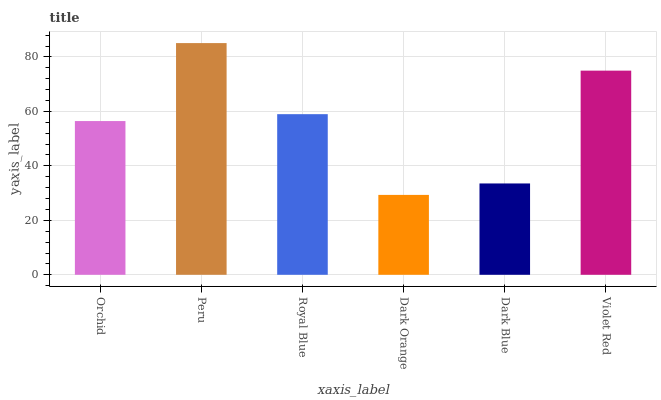Is Dark Orange the minimum?
Answer yes or no. Yes. Is Peru the maximum?
Answer yes or no. Yes. Is Royal Blue the minimum?
Answer yes or no. No. Is Royal Blue the maximum?
Answer yes or no. No. Is Peru greater than Royal Blue?
Answer yes or no. Yes. Is Royal Blue less than Peru?
Answer yes or no. Yes. Is Royal Blue greater than Peru?
Answer yes or no. No. Is Peru less than Royal Blue?
Answer yes or no. No. Is Royal Blue the high median?
Answer yes or no. Yes. Is Orchid the low median?
Answer yes or no. Yes. Is Orchid the high median?
Answer yes or no. No. Is Peru the low median?
Answer yes or no. No. 